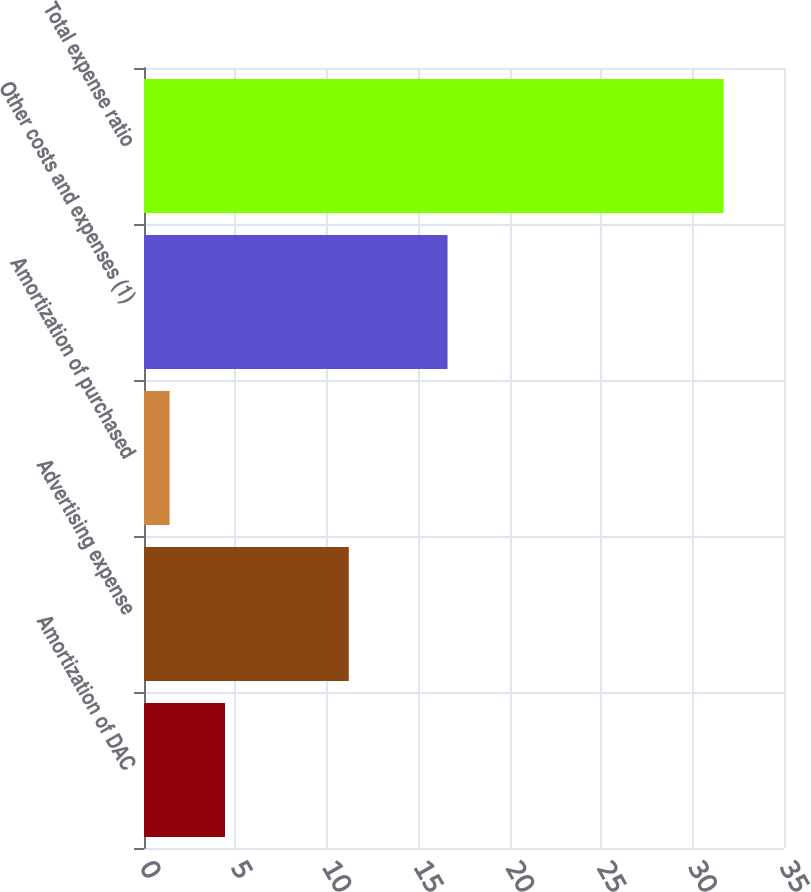<chart> <loc_0><loc_0><loc_500><loc_500><bar_chart><fcel>Amortization of DAC<fcel>Advertising expense<fcel>Amortization of purchased<fcel>Other costs and expenses (1)<fcel>Total expense ratio<nl><fcel>4.43<fcel>11.2<fcel>1.4<fcel>16.6<fcel>31.7<nl></chart> 